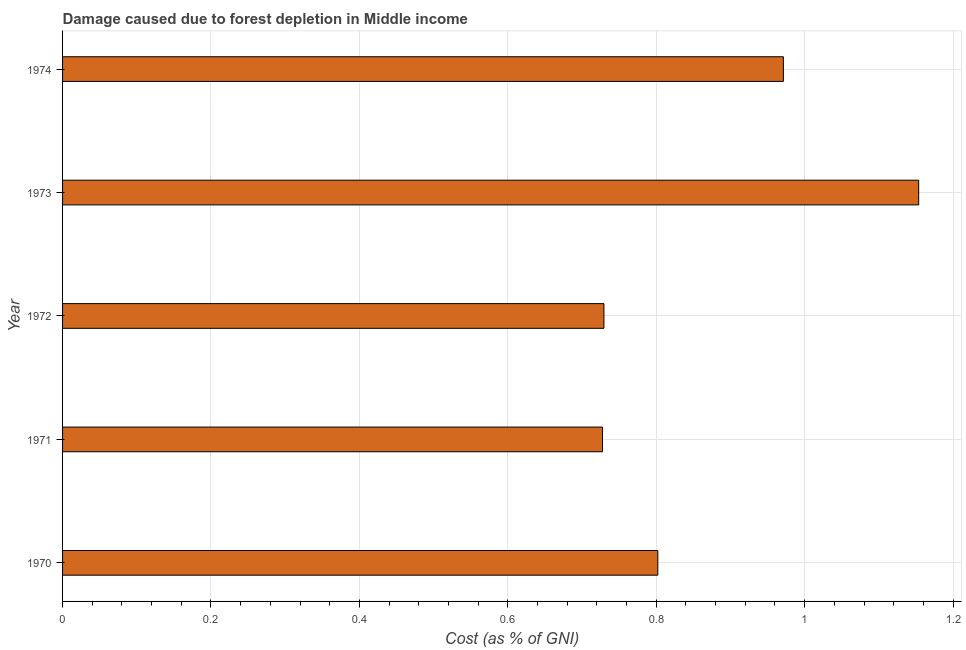Does the graph contain any zero values?
Your answer should be very brief. No. Does the graph contain grids?
Make the answer very short. Yes. What is the title of the graph?
Your answer should be very brief. Damage caused due to forest depletion in Middle income. What is the label or title of the X-axis?
Your answer should be compact. Cost (as % of GNI). What is the damage caused due to forest depletion in 1974?
Make the answer very short. 0.97. Across all years, what is the maximum damage caused due to forest depletion?
Ensure brevity in your answer.  1.15. Across all years, what is the minimum damage caused due to forest depletion?
Keep it short and to the point. 0.73. In which year was the damage caused due to forest depletion maximum?
Your answer should be very brief. 1973. In which year was the damage caused due to forest depletion minimum?
Ensure brevity in your answer.  1971. What is the sum of the damage caused due to forest depletion?
Keep it short and to the point. 4.38. What is the difference between the damage caused due to forest depletion in 1971 and 1973?
Your response must be concise. -0.43. What is the average damage caused due to forest depletion per year?
Your answer should be very brief. 0.88. What is the median damage caused due to forest depletion?
Provide a succinct answer. 0.8. What is the ratio of the damage caused due to forest depletion in 1972 to that in 1973?
Your answer should be compact. 0.63. Is the damage caused due to forest depletion in 1970 less than that in 1972?
Your response must be concise. No. What is the difference between the highest and the second highest damage caused due to forest depletion?
Provide a short and direct response. 0.18. What is the difference between the highest and the lowest damage caused due to forest depletion?
Make the answer very short. 0.43. How many bars are there?
Your answer should be compact. 5. How many years are there in the graph?
Your response must be concise. 5. What is the difference between two consecutive major ticks on the X-axis?
Your answer should be compact. 0.2. Are the values on the major ticks of X-axis written in scientific E-notation?
Provide a succinct answer. No. What is the Cost (as % of GNI) in 1970?
Ensure brevity in your answer.  0.8. What is the Cost (as % of GNI) in 1971?
Your answer should be very brief. 0.73. What is the Cost (as % of GNI) in 1972?
Keep it short and to the point. 0.73. What is the Cost (as % of GNI) of 1973?
Give a very brief answer. 1.15. What is the Cost (as % of GNI) of 1974?
Provide a succinct answer. 0.97. What is the difference between the Cost (as % of GNI) in 1970 and 1971?
Your response must be concise. 0.07. What is the difference between the Cost (as % of GNI) in 1970 and 1972?
Offer a very short reply. 0.07. What is the difference between the Cost (as % of GNI) in 1970 and 1973?
Provide a short and direct response. -0.35. What is the difference between the Cost (as % of GNI) in 1970 and 1974?
Ensure brevity in your answer.  -0.17. What is the difference between the Cost (as % of GNI) in 1971 and 1972?
Give a very brief answer. -0. What is the difference between the Cost (as % of GNI) in 1971 and 1973?
Give a very brief answer. -0.43. What is the difference between the Cost (as % of GNI) in 1971 and 1974?
Ensure brevity in your answer.  -0.24. What is the difference between the Cost (as % of GNI) in 1972 and 1973?
Ensure brevity in your answer.  -0.42. What is the difference between the Cost (as % of GNI) in 1972 and 1974?
Your answer should be compact. -0.24. What is the difference between the Cost (as % of GNI) in 1973 and 1974?
Provide a short and direct response. 0.18. What is the ratio of the Cost (as % of GNI) in 1970 to that in 1971?
Your response must be concise. 1.1. What is the ratio of the Cost (as % of GNI) in 1970 to that in 1972?
Your answer should be very brief. 1.1. What is the ratio of the Cost (as % of GNI) in 1970 to that in 1973?
Make the answer very short. 0.69. What is the ratio of the Cost (as % of GNI) in 1970 to that in 1974?
Make the answer very short. 0.83. What is the ratio of the Cost (as % of GNI) in 1971 to that in 1972?
Your response must be concise. 1. What is the ratio of the Cost (as % of GNI) in 1971 to that in 1973?
Give a very brief answer. 0.63. What is the ratio of the Cost (as % of GNI) in 1971 to that in 1974?
Keep it short and to the point. 0.75. What is the ratio of the Cost (as % of GNI) in 1972 to that in 1973?
Your response must be concise. 0.63. What is the ratio of the Cost (as % of GNI) in 1972 to that in 1974?
Keep it short and to the point. 0.75. What is the ratio of the Cost (as % of GNI) in 1973 to that in 1974?
Your response must be concise. 1.19. 